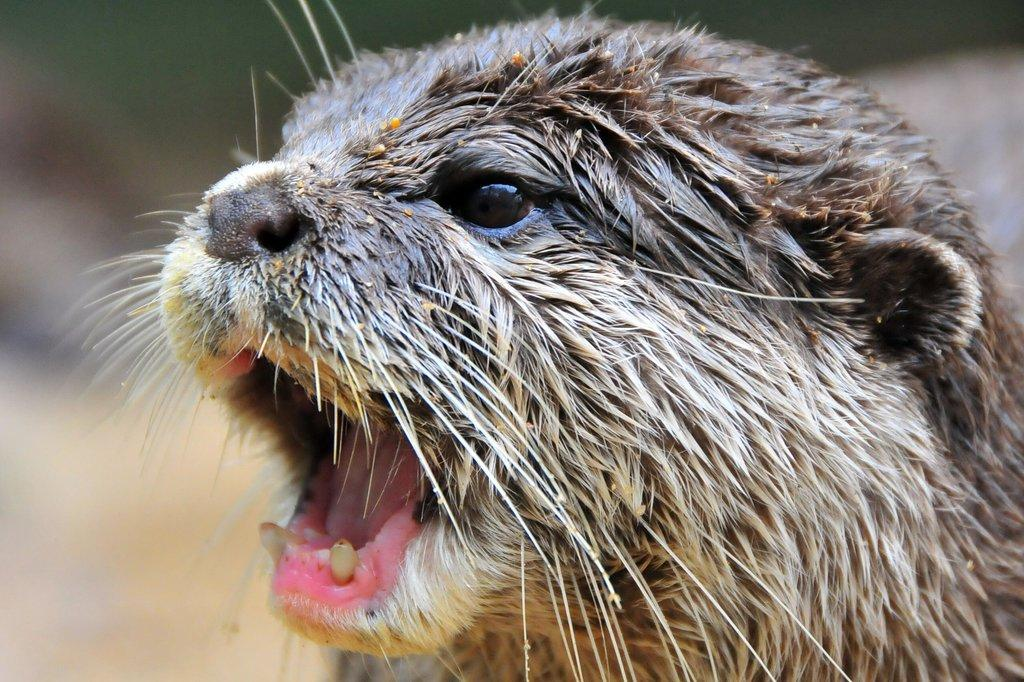What is the main subject of the image? There is an animal in the center of the image. What type of jail can be seen in the image? There is no jail present in the image; it features an animal in the center. How many elbows does the animal have in the image? Animals do not have elbows, so this question cannot be answered based on the image. 